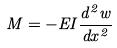Convert formula to latex. <formula><loc_0><loc_0><loc_500><loc_500>M = - E I \frac { d ^ { 2 } w } { d x ^ { 2 } }</formula> 